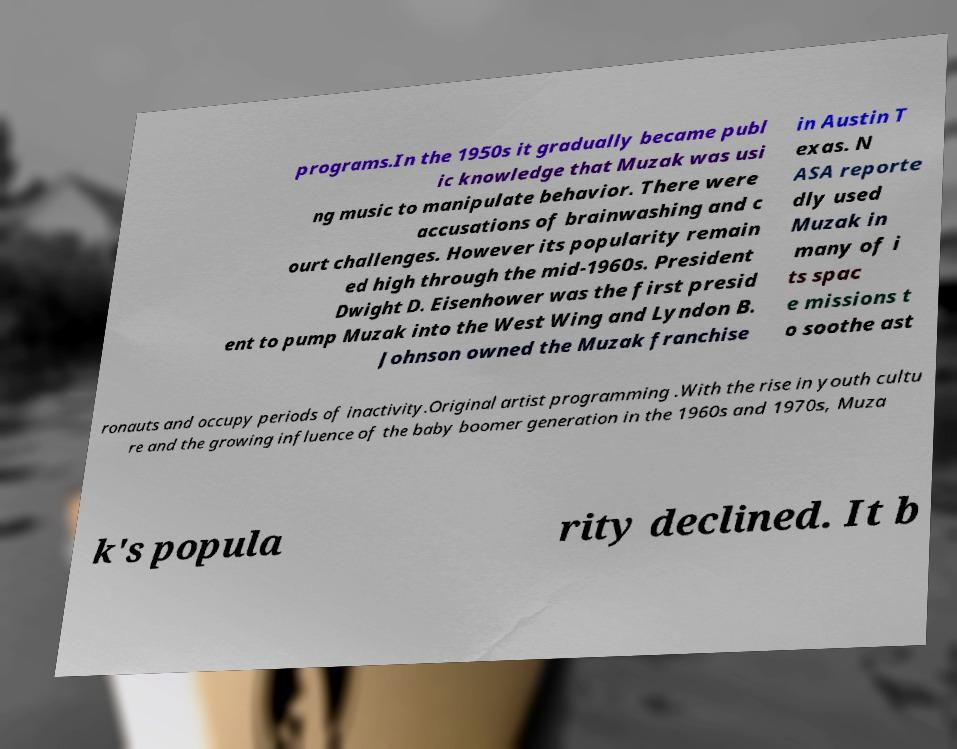I need the written content from this picture converted into text. Can you do that? programs.In the 1950s it gradually became publ ic knowledge that Muzak was usi ng music to manipulate behavior. There were accusations of brainwashing and c ourt challenges. However its popularity remain ed high through the mid-1960s. President Dwight D. Eisenhower was the first presid ent to pump Muzak into the West Wing and Lyndon B. Johnson owned the Muzak franchise in Austin T exas. N ASA reporte dly used Muzak in many of i ts spac e missions t o soothe ast ronauts and occupy periods of inactivity.Original artist programming .With the rise in youth cultu re and the growing influence of the baby boomer generation in the 1960s and 1970s, Muza k's popula rity declined. It b 